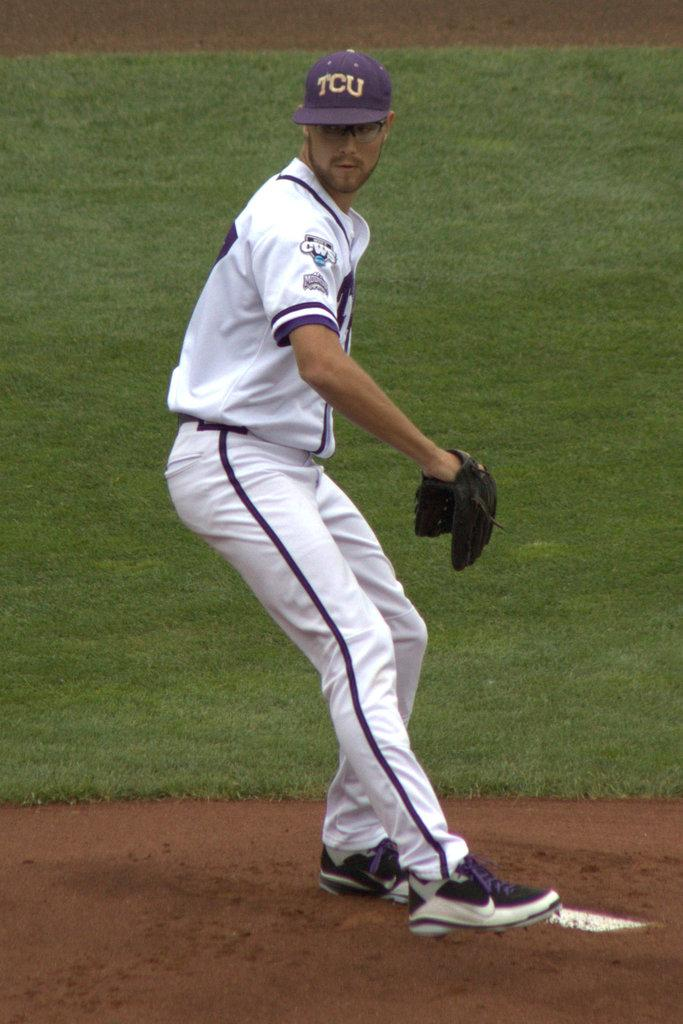<image>
Create a compact narrative representing the image presented. The pitcher plays for the college baseball team TCU. 